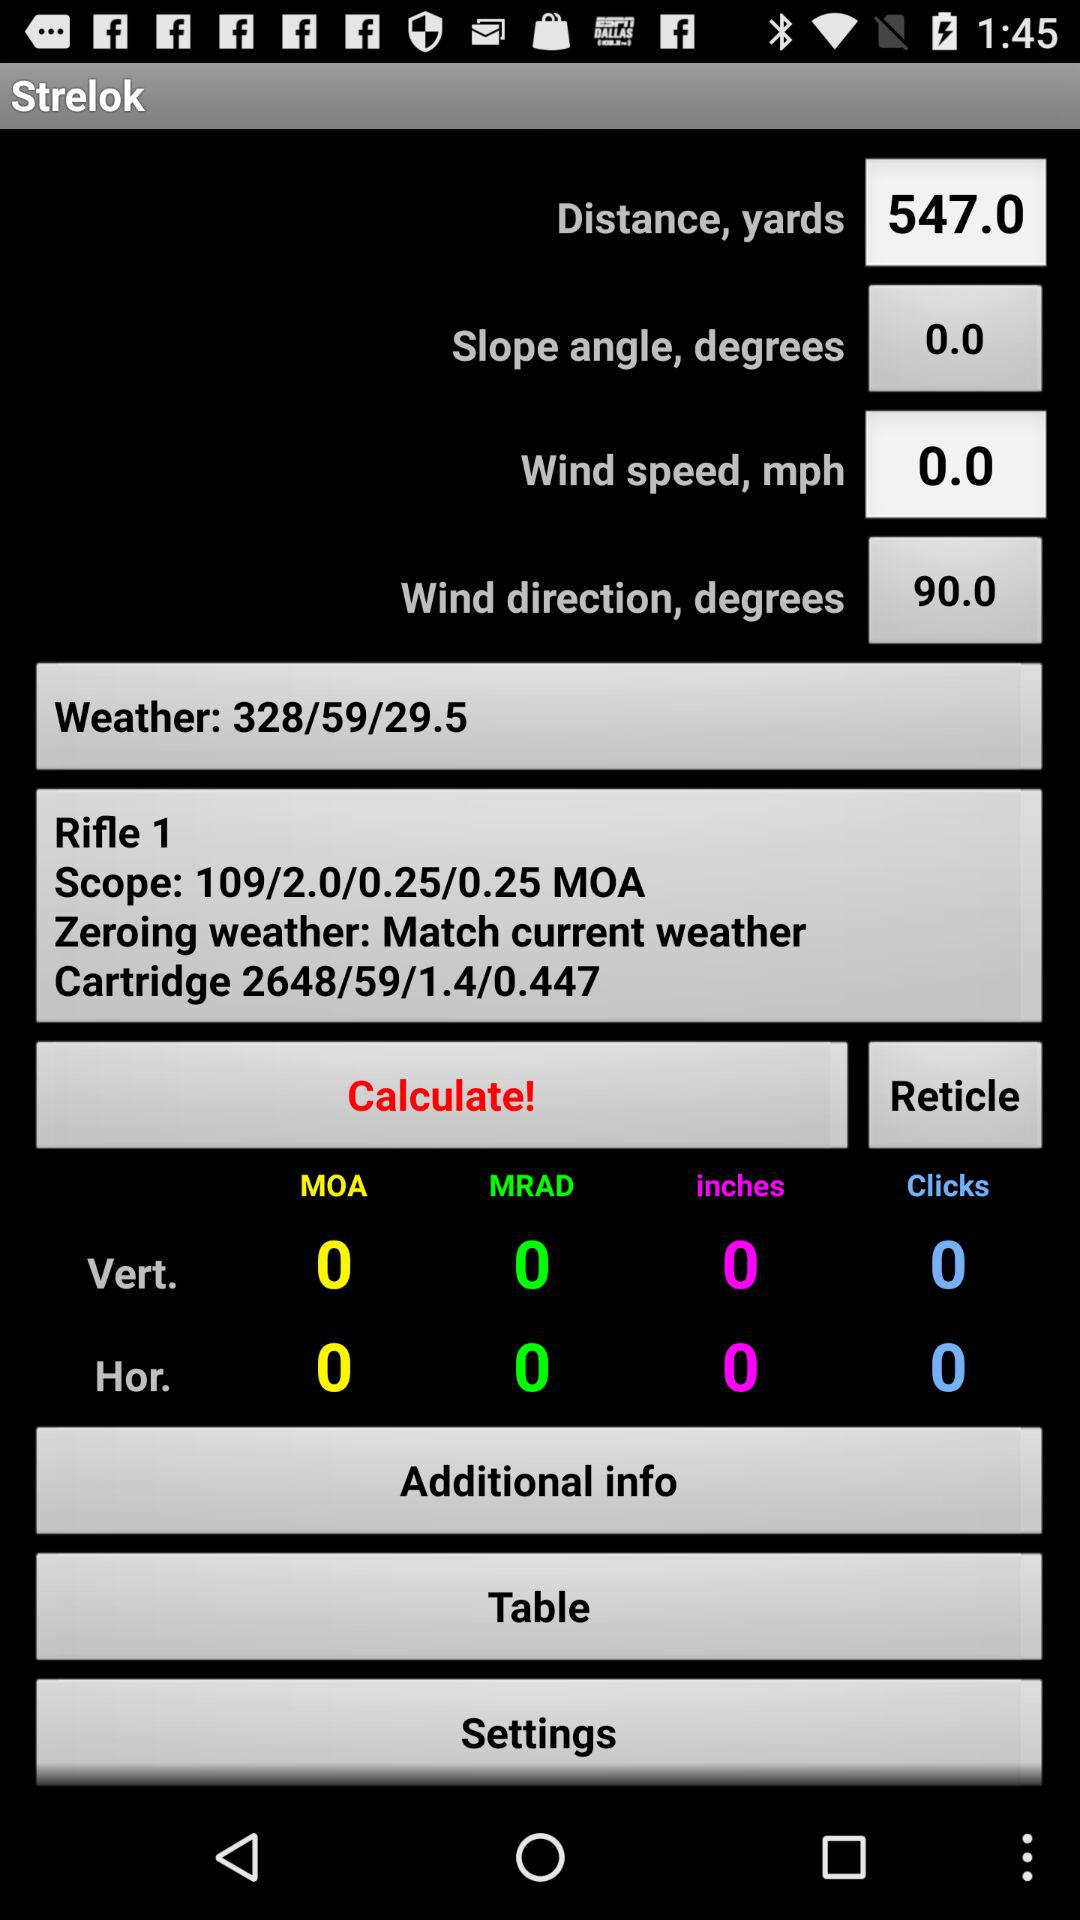What is the distance? The distance is 547.0. 